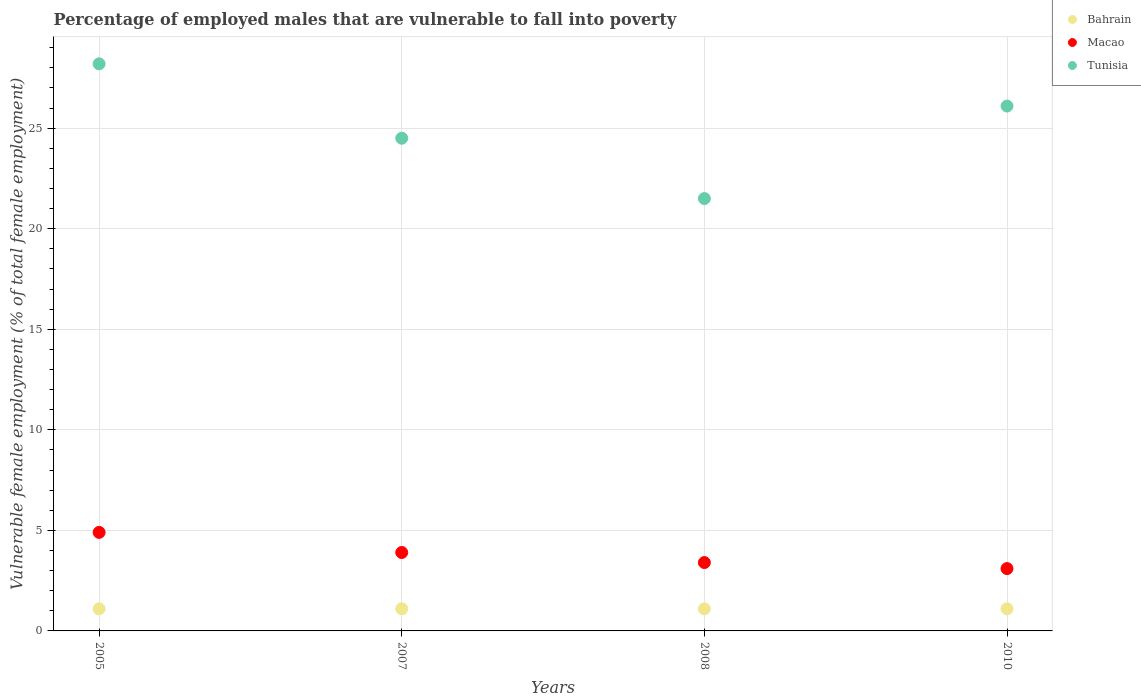How many different coloured dotlines are there?
Provide a short and direct response. 3. Is the number of dotlines equal to the number of legend labels?
Ensure brevity in your answer.  Yes. What is the percentage of employed males who are vulnerable to fall into poverty in Tunisia in 2005?
Your response must be concise. 28.2. Across all years, what is the maximum percentage of employed males who are vulnerable to fall into poverty in Bahrain?
Your answer should be very brief. 1.1. Across all years, what is the minimum percentage of employed males who are vulnerable to fall into poverty in Bahrain?
Ensure brevity in your answer.  1.1. What is the total percentage of employed males who are vulnerable to fall into poverty in Macao in the graph?
Offer a very short reply. 15.3. What is the difference between the percentage of employed males who are vulnerable to fall into poverty in Macao in 2007 and that in 2010?
Your response must be concise. 0.8. What is the difference between the percentage of employed males who are vulnerable to fall into poverty in Bahrain in 2007 and the percentage of employed males who are vulnerable to fall into poverty in Macao in 2008?
Offer a very short reply. -2.3. What is the average percentage of employed males who are vulnerable to fall into poverty in Tunisia per year?
Make the answer very short. 25.08. In the year 2010, what is the difference between the percentage of employed males who are vulnerable to fall into poverty in Bahrain and percentage of employed males who are vulnerable to fall into poverty in Macao?
Ensure brevity in your answer.  -2. What is the ratio of the percentage of employed males who are vulnerable to fall into poverty in Bahrain in 2007 to that in 2008?
Offer a terse response. 1. What is the difference between the highest and the second highest percentage of employed males who are vulnerable to fall into poverty in Tunisia?
Provide a short and direct response. 2.1. What is the difference between the highest and the lowest percentage of employed males who are vulnerable to fall into poverty in Tunisia?
Your answer should be compact. 6.7. In how many years, is the percentage of employed males who are vulnerable to fall into poverty in Tunisia greater than the average percentage of employed males who are vulnerable to fall into poverty in Tunisia taken over all years?
Offer a very short reply. 2. Is it the case that in every year, the sum of the percentage of employed males who are vulnerable to fall into poverty in Tunisia and percentage of employed males who are vulnerable to fall into poverty in Macao  is greater than the percentage of employed males who are vulnerable to fall into poverty in Bahrain?
Offer a terse response. Yes. How many dotlines are there?
Your answer should be very brief. 3. How many years are there in the graph?
Provide a short and direct response. 4. Does the graph contain any zero values?
Offer a terse response. No. Does the graph contain grids?
Make the answer very short. Yes. Where does the legend appear in the graph?
Offer a terse response. Top right. What is the title of the graph?
Make the answer very short. Percentage of employed males that are vulnerable to fall into poverty. Does "Pacific island small states" appear as one of the legend labels in the graph?
Provide a short and direct response. No. What is the label or title of the X-axis?
Give a very brief answer. Years. What is the label or title of the Y-axis?
Your answer should be very brief. Vulnerable female employment (% of total female employment). What is the Vulnerable female employment (% of total female employment) of Bahrain in 2005?
Give a very brief answer. 1.1. What is the Vulnerable female employment (% of total female employment) in Macao in 2005?
Provide a succinct answer. 4.9. What is the Vulnerable female employment (% of total female employment) of Tunisia in 2005?
Offer a terse response. 28.2. What is the Vulnerable female employment (% of total female employment) of Bahrain in 2007?
Give a very brief answer. 1.1. What is the Vulnerable female employment (% of total female employment) of Macao in 2007?
Make the answer very short. 3.9. What is the Vulnerable female employment (% of total female employment) in Tunisia in 2007?
Keep it short and to the point. 24.5. What is the Vulnerable female employment (% of total female employment) in Bahrain in 2008?
Ensure brevity in your answer.  1.1. What is the Vulnerable female employment (% of total female employment) in Macao in 2008?
Provide a succinct answer. 3.4. What is the Vulnerable female employment (% of total female employment) in Tunisia in 2008?
Your answer should be compact. 21.5. What is the Vulnerable female employment (% of total female employment) in Bahrain in 2010?
Offer a very short reply. 1.1. What is the Vulnerable female employment (% of total female employment) in Macao in 2010?
Give a very brief answer. 3.1. What is the Vulnerable female employment (% of total female employment) of Tunisia in 2010?
Provide a short and direct response. 26.1. Across all years, what is the maximum Vulnerable female employment (% of total female employment) of Bahrain?
Make the answer very short. 1.1. Across all years, what is the maximum Vulnerable female employment (% of total female employment) in Macao?
Your answer should be very brief. 4.9. Across all years, what is the maximum Vulnerable female employment (% of total female employment) in Tunisia?
Provide a succinct answer. 28.2. Across all years, what is the minimum Vulnerable female employment (% of total female employment) in Bahrain?
Make the answer very short. 1.1. Across all years, what is the minimum Vulnerable female employment (% of total female employment) in Macao?
Your answer should be very brief. 3.1. Across all years, what is the minimum Vulnerable female employment (% of total female employment) of Tunisia?
Give a very brief answer. 21.5. What is the total Vulnerable female employment (% of total female employment) in Macao in the graph?
Your answer should be compact. 15.3. What is the total Vulnerable female employment (% of total female employment) in Tunisia in the graph?
Your answer should be compact. 100.3. What is the difference between the Vulnerable female employment (% of total female employment) of Macao in 2005 and that in 2007?
Offer a very short reply. 1. What is the difference between the Vulnerable female employment (% of total female employment) of Bahrain in 2005 and that in 2008?
Provide a short and direct response. 0. What is the difference between the Vulnerable female employment (% of total female employment) of Bahrain in 2005 and that in 2010?
Provide a succinct answer. 0. What is the difference between the Vulnerable female employment (% of total female employment) in Macao in 2005 and that in 2010?
Make the answer very short. 1.8. What is the difference between the Vulnerable female employment (% of total female employment) of Macao in 2007 and that in 2008?
Provide a succinct answer. 0.5. What is the difference between the Vulnerable female employment (% of total female employment) of Macao in 2007 and that in 2010?
Provide a short and direct response. 0.8. What is the difference between the Vulnerable female employment (% of total female employment) of Bahrain in 2008 and that in 2010?
Give a very brief answer. 0. What is the difference between the Vulnerable female employment (% of total female employment) of Bahrain in 2005 and the Vulnerable female employment (% of total female employment) of Tunisia in 2007?
Offer a terse response. -23.4. What is the difference between the Vulnerable female employment (% of total female employment) of Macao in 2005 and the Vulnerable female employment (% of total female employment) of Tunisia in 2007?
Your answer should be compact. -19.6. What is the difference between the Vulnerable female employment (% of total female employment) in Bahrain in 2005 and the Vulnerable female employment (% of total female employment) in Macao in 2008?
Offer a terse response. -2.3. What is the difference between the Vulnerable female employment (% of total female employment) in Bahrain in 2005 and the Vulnerable female employment (% of total female employment) in Tunisia in 2008?
Your answer should be compact. -20.4. What is the difference between the Vulnerable female employment (% of total female employment) of Macao in 2005 and the Vulnerable female employment (% of total female employment) of Tunisia in 2008?
Offer a terse response. -16.6. What is the difference between the Vulnerable female employment (% of total female employment) of Bahrain in 2005 and the Vulnerable female employment (% of total female employment) of Macao in 2010?
Offer a very short reply. -2. What is the difference between the Vulnerable female employment (% of total female employment) of Bahrain in 2005 and the Vulnerable female employment (% of total female employment) of Tunisia in 2010?
Keep it short and to the point. -25. What is the difference between the Vulnerable female employment (% of total female employment) in Macao in 2005 and the Vulnerable female employment (% of total female employment) in Tunisia in 2010?
Your answer should be compact. -21.2. What is the difference between the Vulnerable female employment (% of total female employment) in Bahrain in 2007 and the Vulnerable female employment (% of total female employment) in Macao in 2008?
Your answer should be very brief. -2.3. What is the difference between the Vulnerable female employment (% of total female employment) of Bahrain in 2007 and the Vulnerable female employment (% of total female employment) of Tunisia in 2008?
Keep it short and to the point. -20.4. What is the difference between the Vulnerable female employment (% of total female employment) of Macao in 2007 and the Vulnerable female employment (% of total female employment) of Tunisia in 2008?
Provide a short and direct response. -17.6. What is the difference between the Vulnerable female employment (% of total female employment) in Bahrain in 2007 and the Vulnerable female employment (% of total female employment) in Tunisia in 2010?
Ensure brevity in your answer.  -25. What is the difference between the Vulnerable female employment (% of total female employment) of Macao in 2007 and the Vulnerable female employment (% of total female employment) of Tunisia in 2010?
Your answer should be compact. -22.2. What is the difference between the Vulnerable female employment (% of total female employment) in Bahrain in 2008 and the Vulnerable female employment (% of total female employment) in Tunisia in 2010?
Your answer should be very brief. -25. What is the difference between the Vulnerable female employment (% of total female employment) of Macao in 2008 and the Vulnerable female employment (% of total female employment) of Tunisia in 2010?
Offer a terse response. -22.7. What is the average Vulnerable female employment (% of total female employment) in Macao per year?
Offer a terse response. 3.83. What is the average Vulnerable female employment (% of total female employment) of Tunisia per year?
Your answer should be very brief. 25.07. In the year 2005, what is the difference between the Vulnerable female employment (% of total female employment) in Bahrain and Vulnerable female employment (% of total female employment) in Tunisia?
Make the answer very short. -27.1. In the year 2005, what is the difference between the Vulnerable female employment (% of total female employment) in Macao and Vulnerable female employment (% of total female employment) in Tunisia?
Give a very brief answer. -23.3. In the year 2007, what is the difference between the Vulnerable female employment (% of total female employment) of Bahrain and Vulnerable female employment (% of total female employment) of Tunisia?
Your response must be concise. -23.4. In the year 2007, what is the difference between the Vulnerable female employment (% of total female employment) in Macao and Vulnerable female employment (% of total female employment) in Tunisia?
Your response must be concise. -20.6. In the year 2008, what is the difference between the Vulnerable female employment (% of total female employment) in Bahrain and Vulnerable female employment (% of total female employment) in Macao?
Your answer should be very brief. -2.3. In the year 2008, what is the difference between the Vulnerable female employment (% of total female employment) of Bahrain and Vulnerable female employment (% of total female employment) of Tunisia?
Give a very brief answer. -20.4. In the year 2008, what is the difference between the Vulnerable female employment (% of total female employment) of Macao and Vulnerable female employment (% of total female employment) of Tunisia?
Make the answer very short. -18.1. In the year 2010, what is the difference between the Vulnerable female employment (% of total female employment) in Bahrain and Vulnerable female employment (% of total female employment) in Tunisia?
Your answer should be very brief. -25. What is the ratio of the Vulnerable female employment (% of total female employment) in Bahrain in 2005 to that in 2007?
Make the answer very short. 1. What is the ratio of the Vulnerable female employment (% of total female employment) in Macao in 2005 to that in 2007?
Keep it short and to the point. 1.26. What is the ratio of the Vulnerable female employment (% of total female employment) in Tunisia in 2005 to that in 2007?
Offer a very short reply. 1.15. What is the ratio of the Vulnerable female employment (% of total female employment) of Bahrain in 2005 to that in 2008?
Ensure brevity in your answer.  1. What is the ratio of the Vulnerable female employment (% of total female employment) of Macao in 2005 to that in 2008?
Your answer should be compact. 1.44. What is the ratio of the Vulnerable female employment (% of total female employment) of Tunisia in 2005 to that in 2008?
Your answer should be very brief. 1.31. What is the ratio of the Vulnerable female employment (% of total female employment) of Macao in 2005 to that in 2010?
Ensure brevity in your answer.  1.58. What is the ratio of the Vulnerable female employment (% of total female employment) of Tunisia in 2005 to that in 2010?
Your response must be concise. 1.08. What is the ratio of the Vulnerable female employment (% of total female employment) of Bahrain in 2007 to that in 2008?
Make the answer very short. 1. What is the ratio of the Vulnerable female employment (% of total female employment) of Macao in 2007 to that in 2008?
Your answer should be compact. 1.15. What is the ratio of the Vulnerable female employment (% of total female employment) in Tunisia in 2007 to that in 2008?
Your answer should be very brief. 1.14. What is the ratio of the Vulnerable female employment (% of total female employment) of Macao in 2007 to that in 2010?
Your answer should be very brief. 1.26. What is the ratio of the Vulnerable female employment (% of total female employment) of Tunisia in 2007 to that in 2010?
Your response must be concise. 0.94. What is the ratio of the Vulnerable female employment (% of total female employment) of Bahrain in 2008 to that in 2010?
Provide a succinct answer. 1. What is the ratio of the Vulnerable female employment (% of total female employment) of Macao in 2008 to that in 2010?
Provide a short and direct response. 1.1. What is the ratio of the Vulnerable female employment (% of total female employment) in Tunisia in 2008 to that in 2010?
Keep it short and to the point. 0.82. What is the difference between the highest and the second highest Vulnerable female employment (% of total female employment) in Tunisia?
Give a very brief answer. 2.1. What is the difference between the highest and the lowest Vulnerable female employment (% of total female employment) in Bahrain?
Keep it short and to the point. 0. What is the difference between the highest and the lowest Vulnerable female employment (% of total female employment) in Macao?
Ensure brevity in your answer.  1.8. 